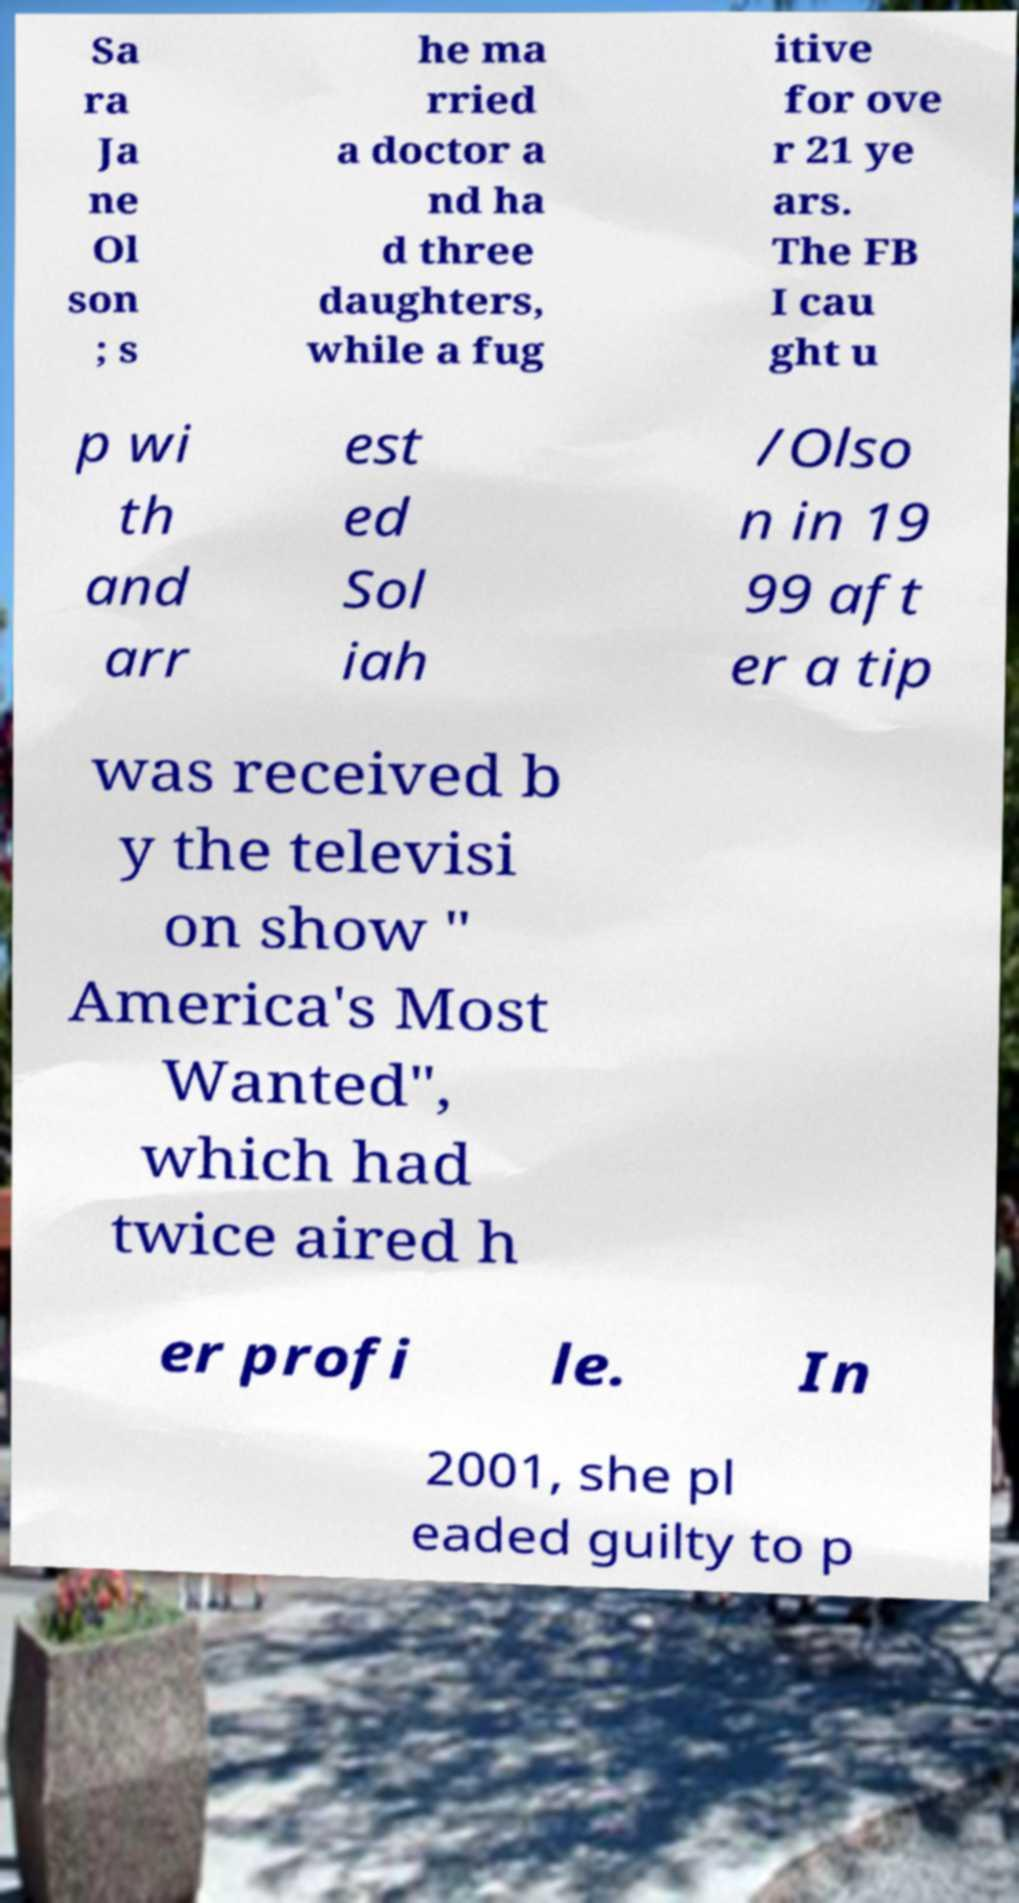I need the written content from this picture converted into text. Can you do that? Sa ra Ja ne Ol son ; s he ma rried a doctor a nd ha d three daughters, while a fug itive for ove r 21 ye ars. The FB I cau ght u p wi th and arr est ed Sol iah /Olso n in 19 99 aft er a tip was received b y the televisi on show " America's Most Wanted", which had twice aired h er profi le. In 2001, she pl eaded guilty to p 